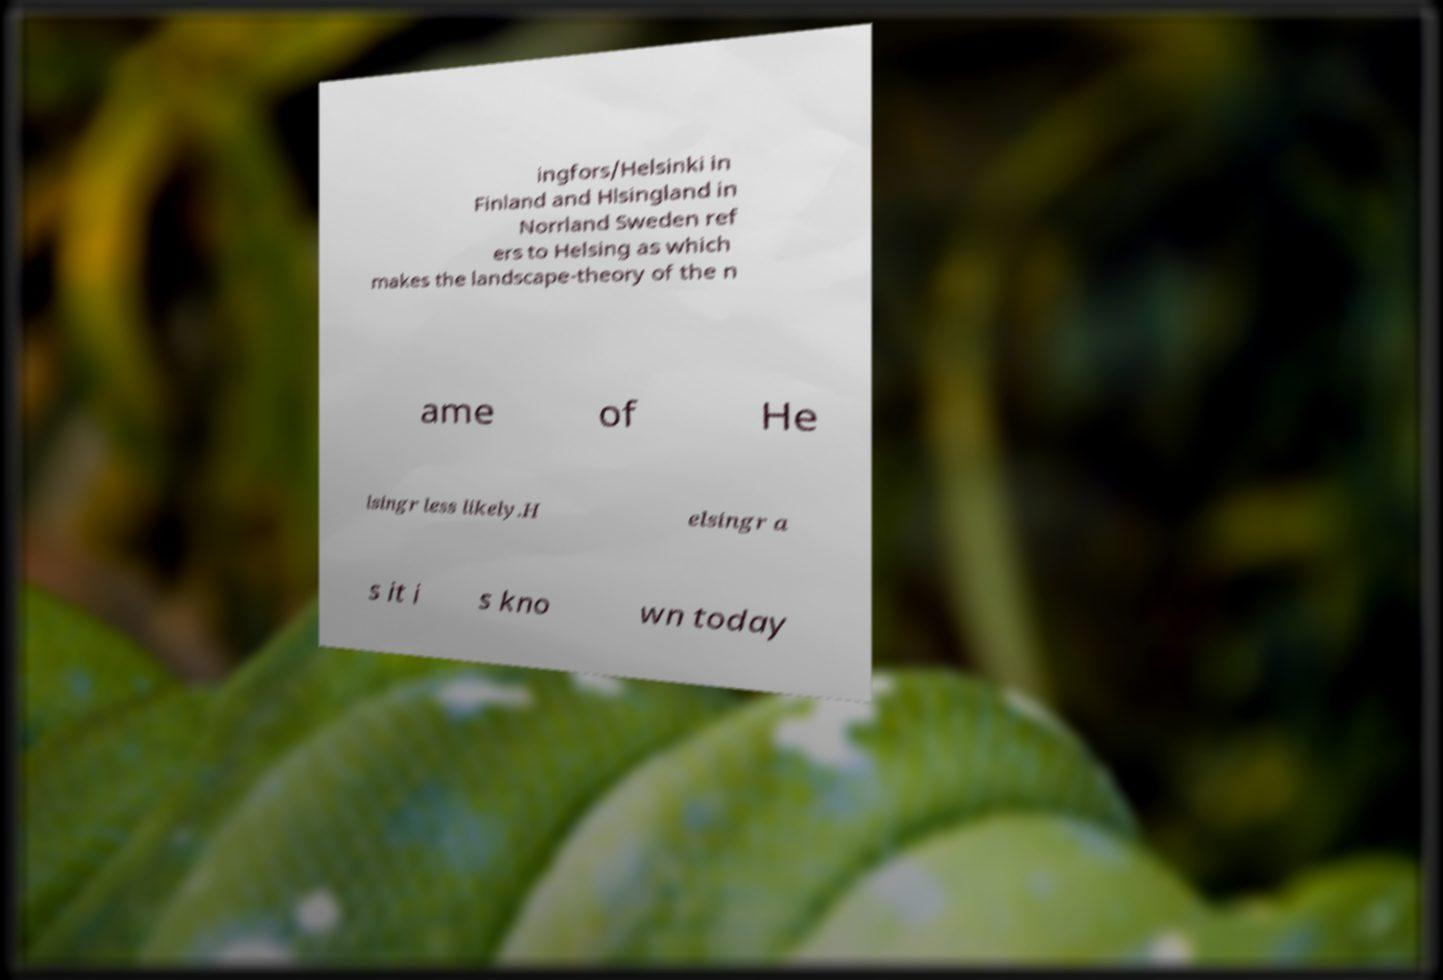What messages or text are displayed in this image? I need them in a readable, typed format. ingfors/Helsinki in Finland and Hlsingland in Norrland Sweden ref ers to Helsing as which makes the landscape-theory of the n ame of He lsingr less likely.H elsingr a s it i s kno wn today 